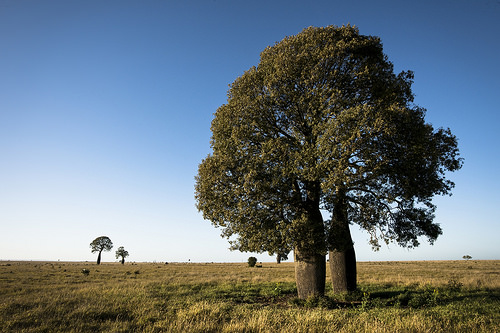<image>
Can you confirm if the tree is next to the grass? Yes. The tree is positioned adjacent to the grass, located nearby in the same general area. Where is the tree in relation to the tree? Is it behind the tree? Yes. From this viewpoint, the tree is positioned behind the tree, with the tree partially or fully occluding the tree. 